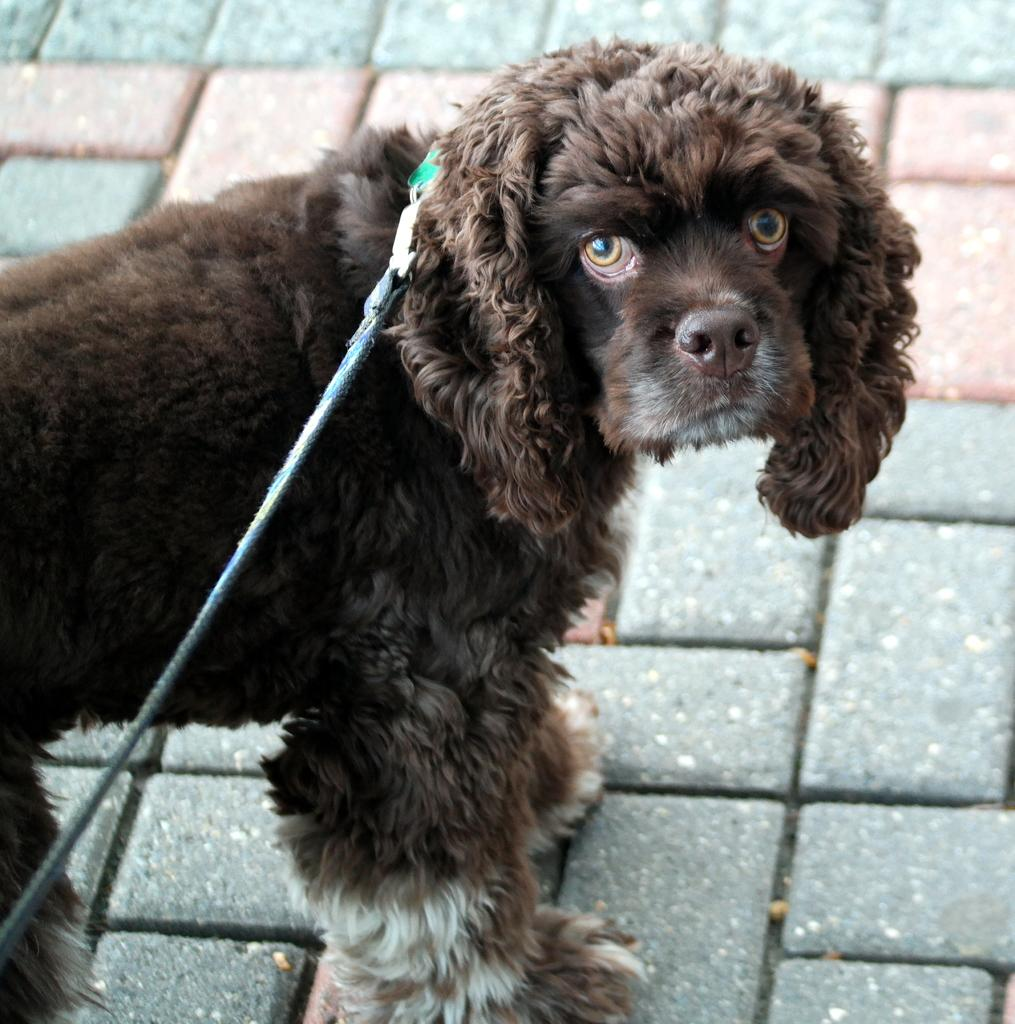Where was the image taken? The image is taken outdoors. What is at the bottom of the image? There is a floor at the bottom of the image. What can be seen on the left side of the image? There is a dog on the left side of the image. How is the dog secured in the image? The dog is tied with a belt. What day of the week is it in the image? The day of the week is not mentioned or visible in the image, so it cannot be determined. 